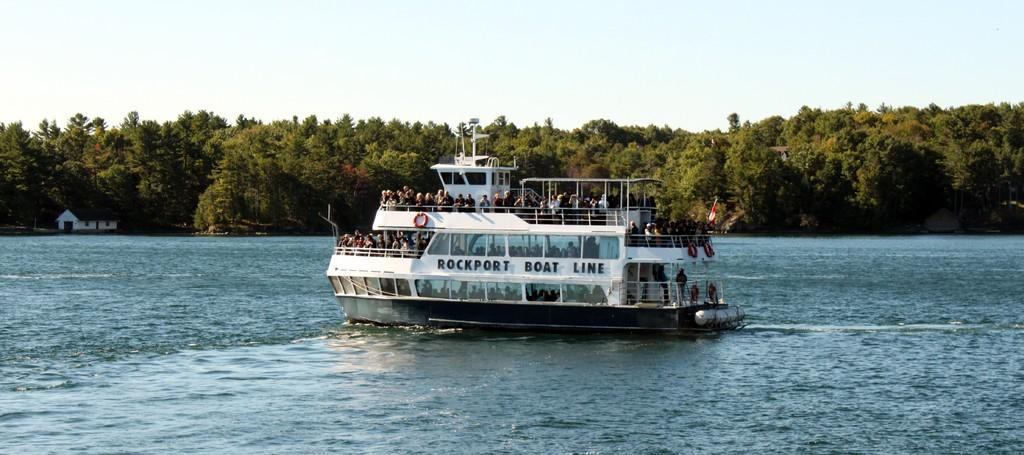What are the people doing in the image? The people are on a boat in the image. Where is the boat located? The boat is on the water. What can be seen behind the water in the image? There is a wooden house behind the water. What type of vegetation is visible in the image? Trees are visible in the image. Can you see the people's toes in the image? There is no indication of the people's toes being visible in the image. What type of sea creature can be seen swimming near the boat? There is no sea creature visible in the image; it only features people on a boat, water, a wooden house, and trees. 